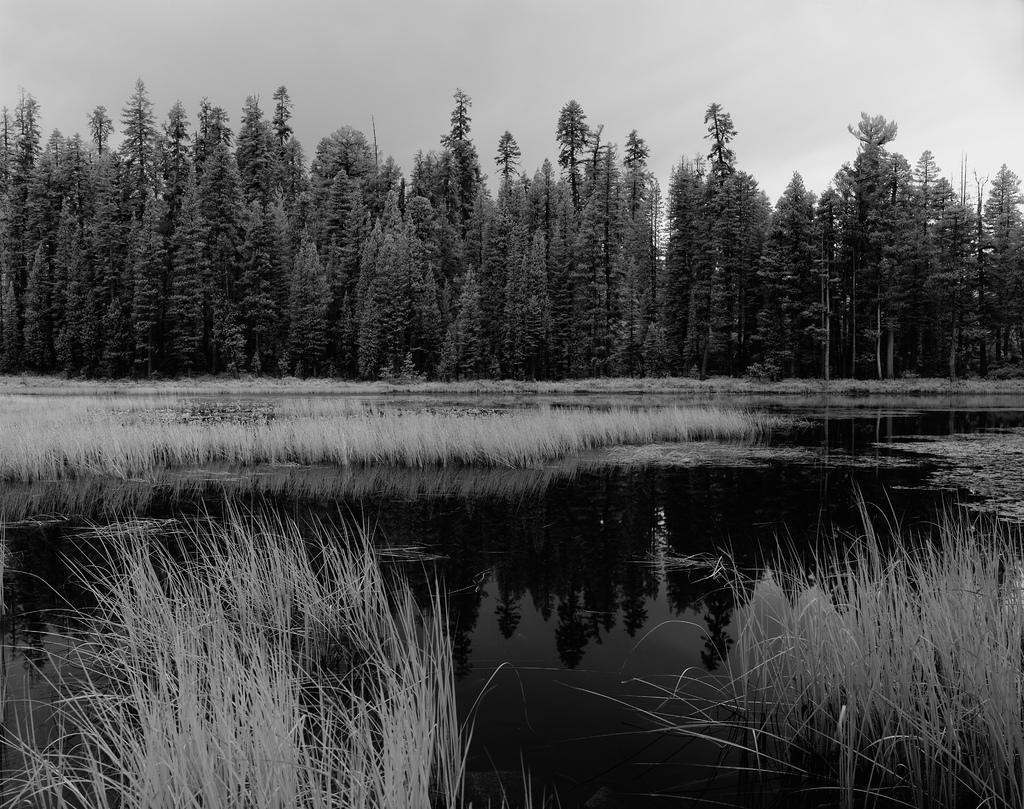What type of body of water is present in the image? is holding a locket. A: There is a lake in the picture. What is unusual about the lake in the image? There is grass in the lake. What can be seen in the background of the picture? There are trees in the background of the picture. How would you describe the sky in the image? The sky is cloudy. How many cobwebs can be seen hanging from the trees in the image? There are no cobwebs visible in the image; it only features a lake, grass in the lake, trees in the background, and a cloudy sky. 